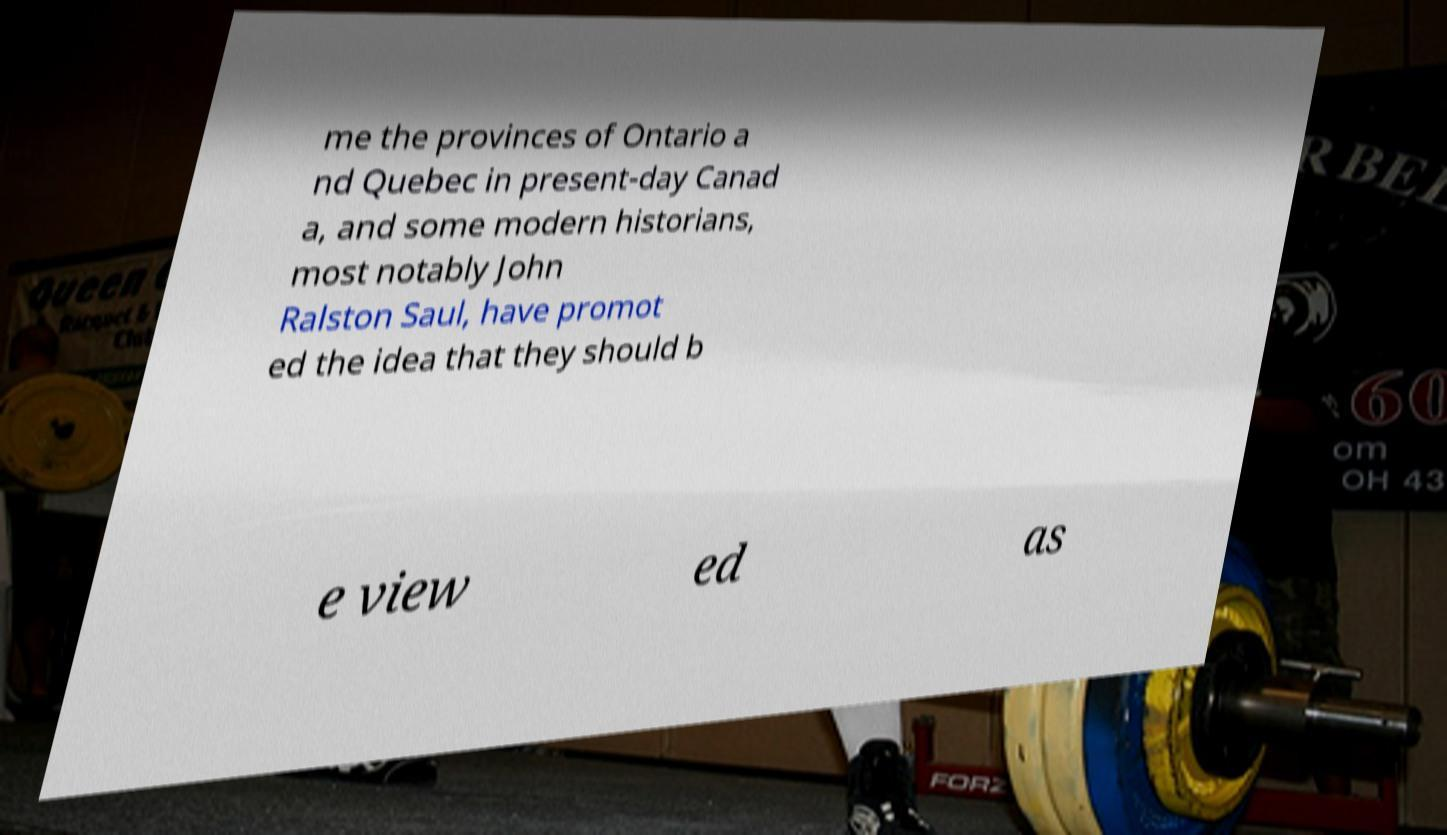Please read and relay the text visible in this image. What does it say? me the provinces of Ontario a nd Quebec in present-day Canad a, and some modern historians, most notably John Ralston Saul, have promot ed the idea that they should b e view ed as 